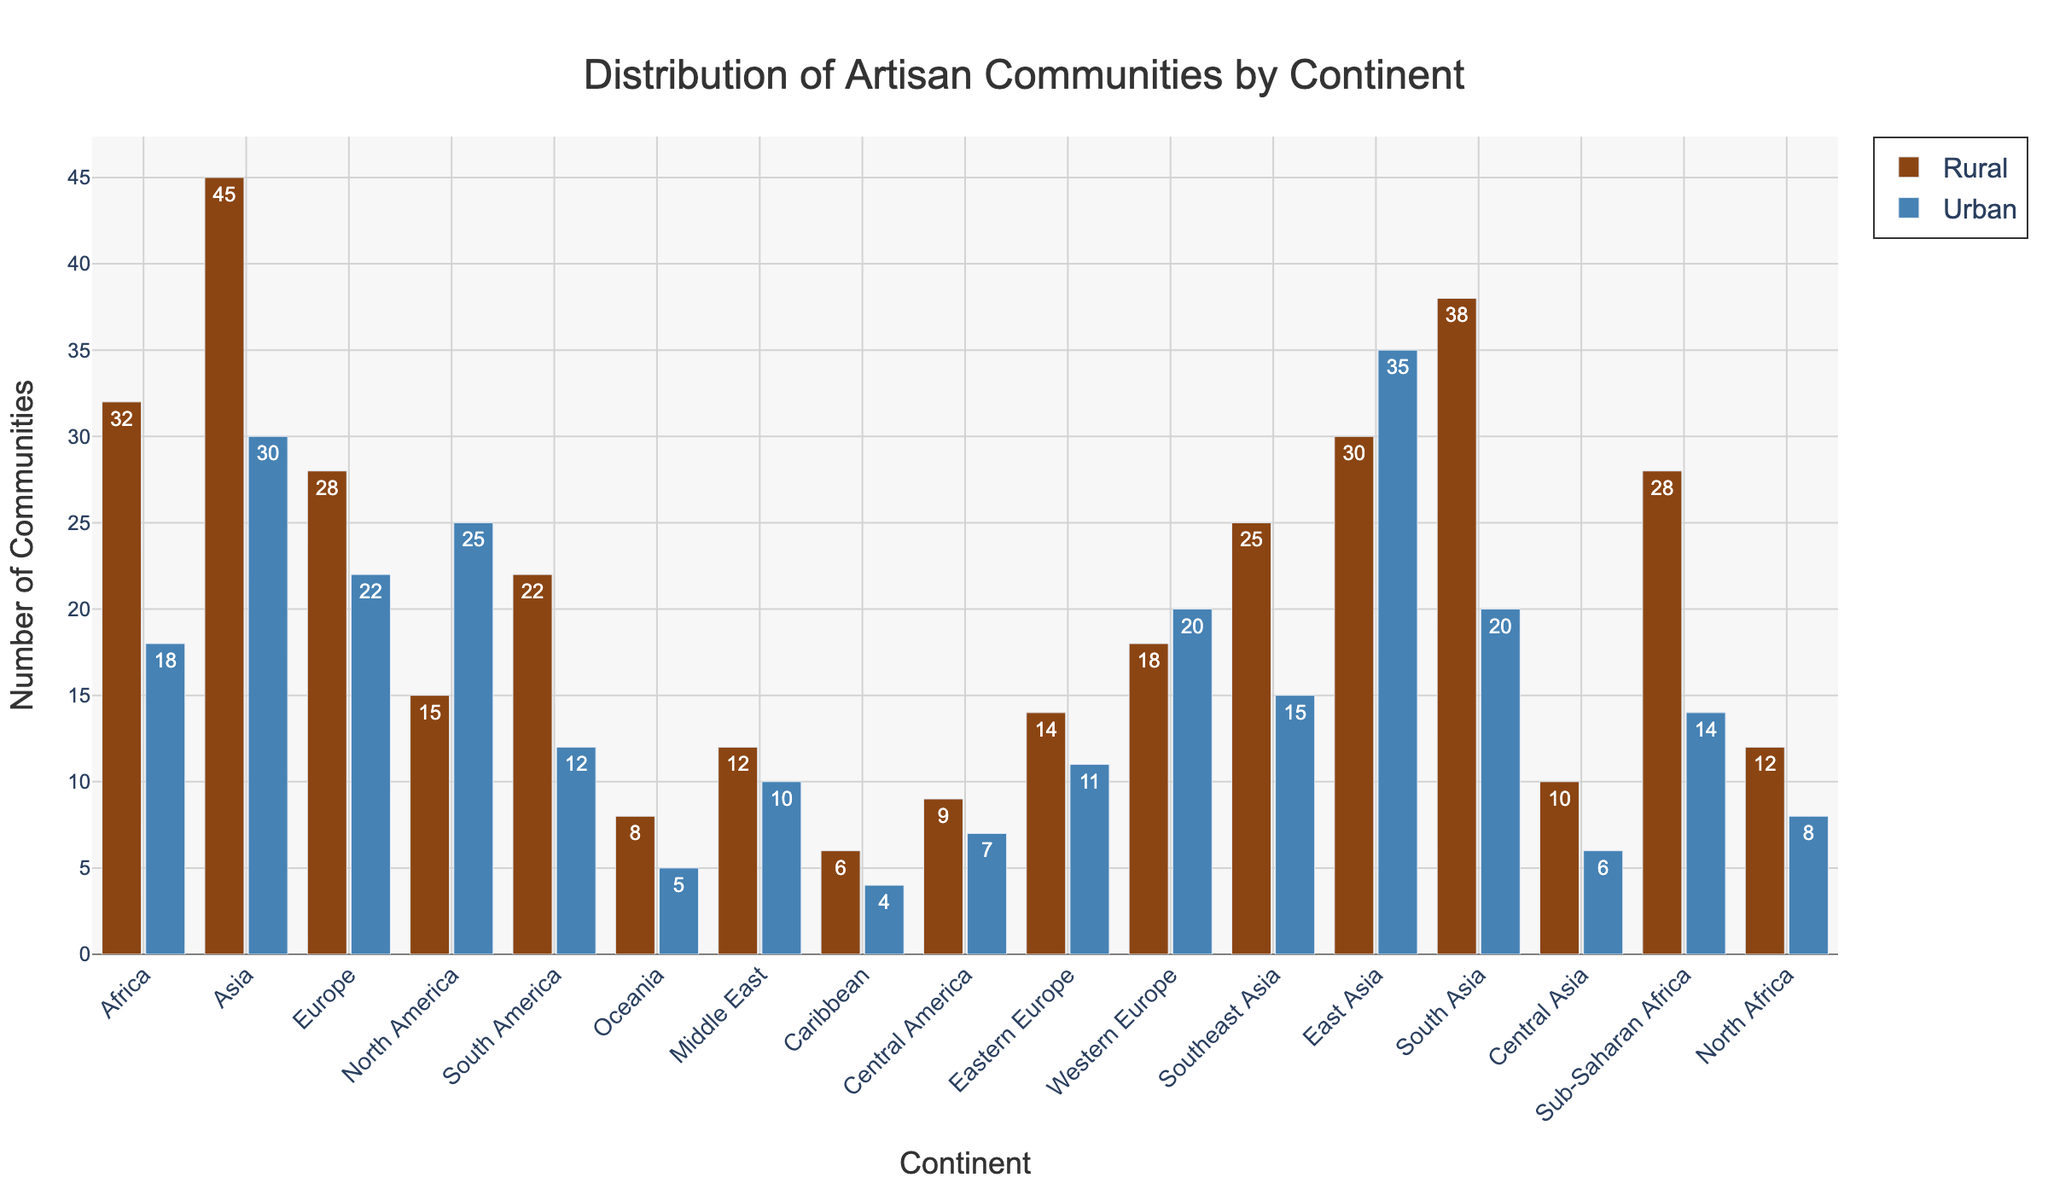Which continent has the highest number of rural artisan communities? By observing the height of the bars for rural areas in each continent, Asia has the tallest bar representing 45 rural artisan communities.
Answer: Asia What's the total number of artisan communities (rural and urban) in North America? North America has 15 rural and 25 urban artisan communities. Adding these gives 15 + 25 = 40.
Answer: 40 Which regions in Africa (Sub-Saharan Africa or North Africa) have more urban artisan communities, and by how much? Sub-Saharan Africa has 14 urban communities while North Africa has 8. The difference is 14 - 8 = 6.
Answer: Sub-Saharan Africa by 6 How does the number of urban artisan communities in Europe compare to the number in Asia? The sum of urban artisan communities in Europe is 22 (Western Europe) + 11 (Eastern Europe) = 33. Asia has 30 + 35 (East Asia) + 20 (South Asia) + 15 (Southeast Asia) + 6 (Central Asia) = 106. So, Europe has fewer urban communities than Asia.
Answer: Asia has more What's the average number of rural artisan communities across South America, Central America, and the Caribbean? South America has 22 rural, Central America has 9, and the Caribbean has 6. Adding these gives 22 + 9 + 6 = 37. Averaging them is 37 / 3 = 12.33.
Answer: 12.33 How many regions have more urban artisan communities than rural ones? By comparing the counts for each region, the following have more urban than rural: North America and East Asia. This makes a total of 2 regions.
Answer: 2 What's the difference between the total artisan communities (rural + urban) in Oceania and the Caribbean? Oceania has 8 rural + 5 urban = 13 and the Caribbean has 6 rural + 4 urban = 10. The difference is 13 - 10 = 3.
Answer: 3 Which continent has a more balanced distribution of rural and urban artisan communities, considering the smallest difference between rural and urban numbers? Europe (Western Europe) has 18 rural and 20 urban, making the difference 20 - 18 = 2, which is the smallest gap.
Answer: Western Europe What's the median value of urban artisan communities among the listed regions? Listing the urban communities values in ascending order: 4, 5, 6, 7, 8, 10, 11, 12, 14, 15, 18, 20, 22, 25, 30, 35. With 16 values, the median is the average of the 8th and 9th values: (12 + 14) / 2 = 13.
Answer: 13 